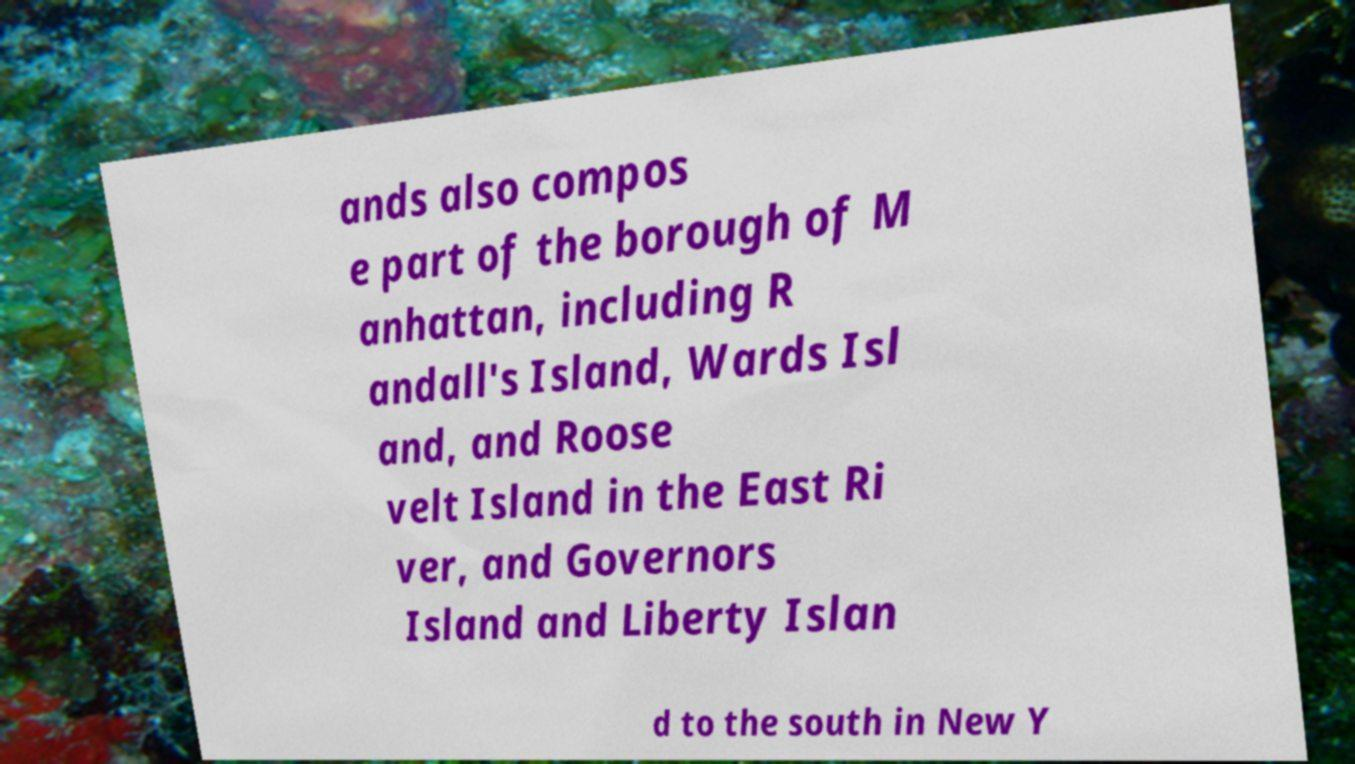Please read and relay the text visible in this image. What does it say? ands also compos e part of the borough of M anhattan, including R andall's Island, Wards Isl and, and Roose velt Island in the East Ri ver, and Governors Island and Liberty Islan d to the south in New Y 